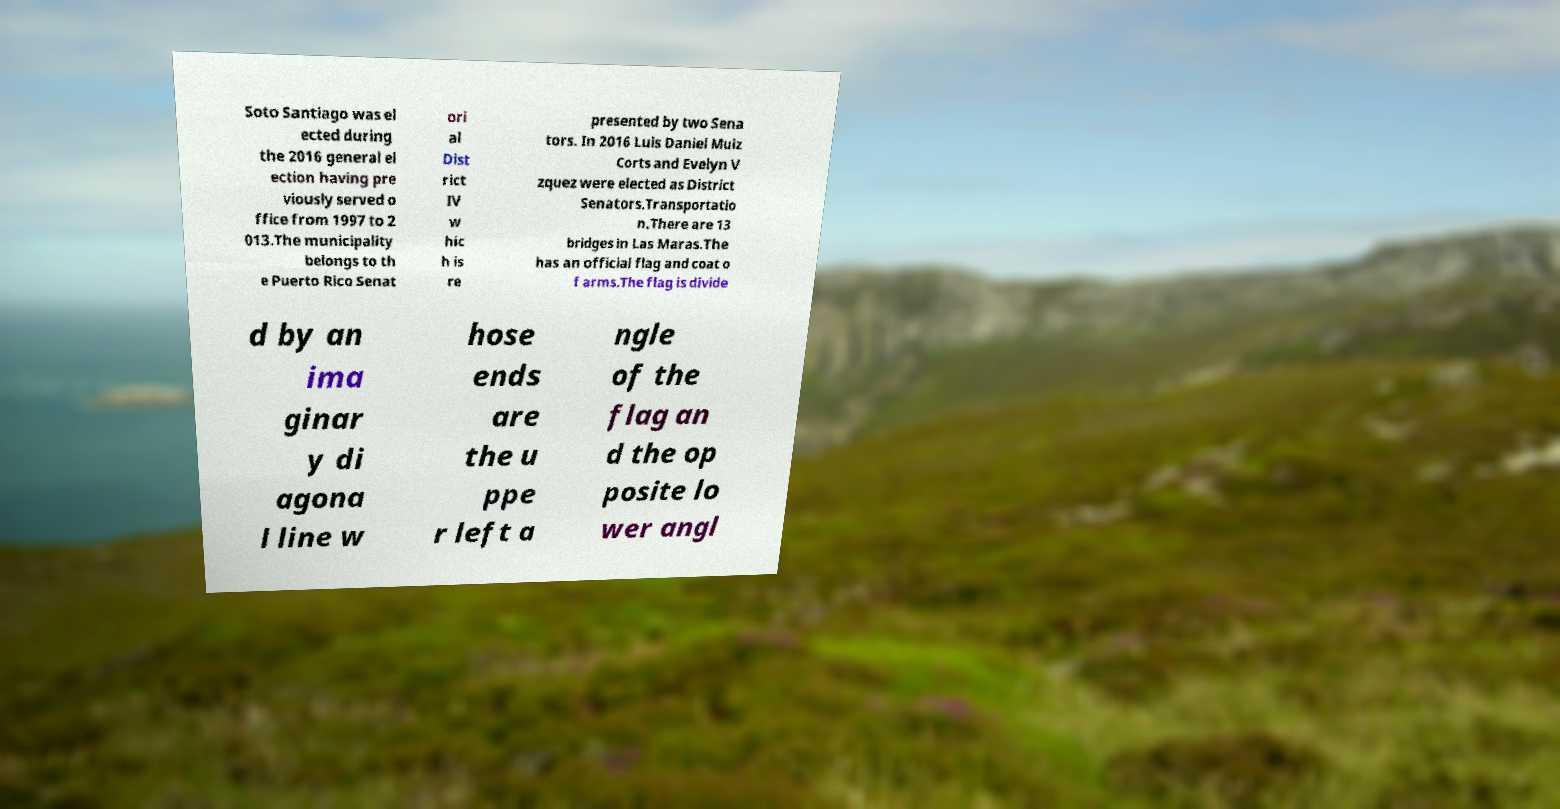I need the written content from this picture converted into text. Can you do that? Soto Santiago was el ected during the 2016 general el ection having pre viously served o ffice from 1997 to 2 013.The municipality belongs to th e Puerto Rico Senat ori al Dist rict IV w hic h is re presented by two Sena tors. In 2016 Luis Daniel Muiz Corts and Evelyn V zquez were elected as District Senators.Transportatio n.There are 13 bridges in Las Maras.The has an official flag and coat o f arms.The flag is divide d by an ima ginar y di agona l line w hose ends are the u ppe r left a ngle of the flag an d the op posite lo wer angl 